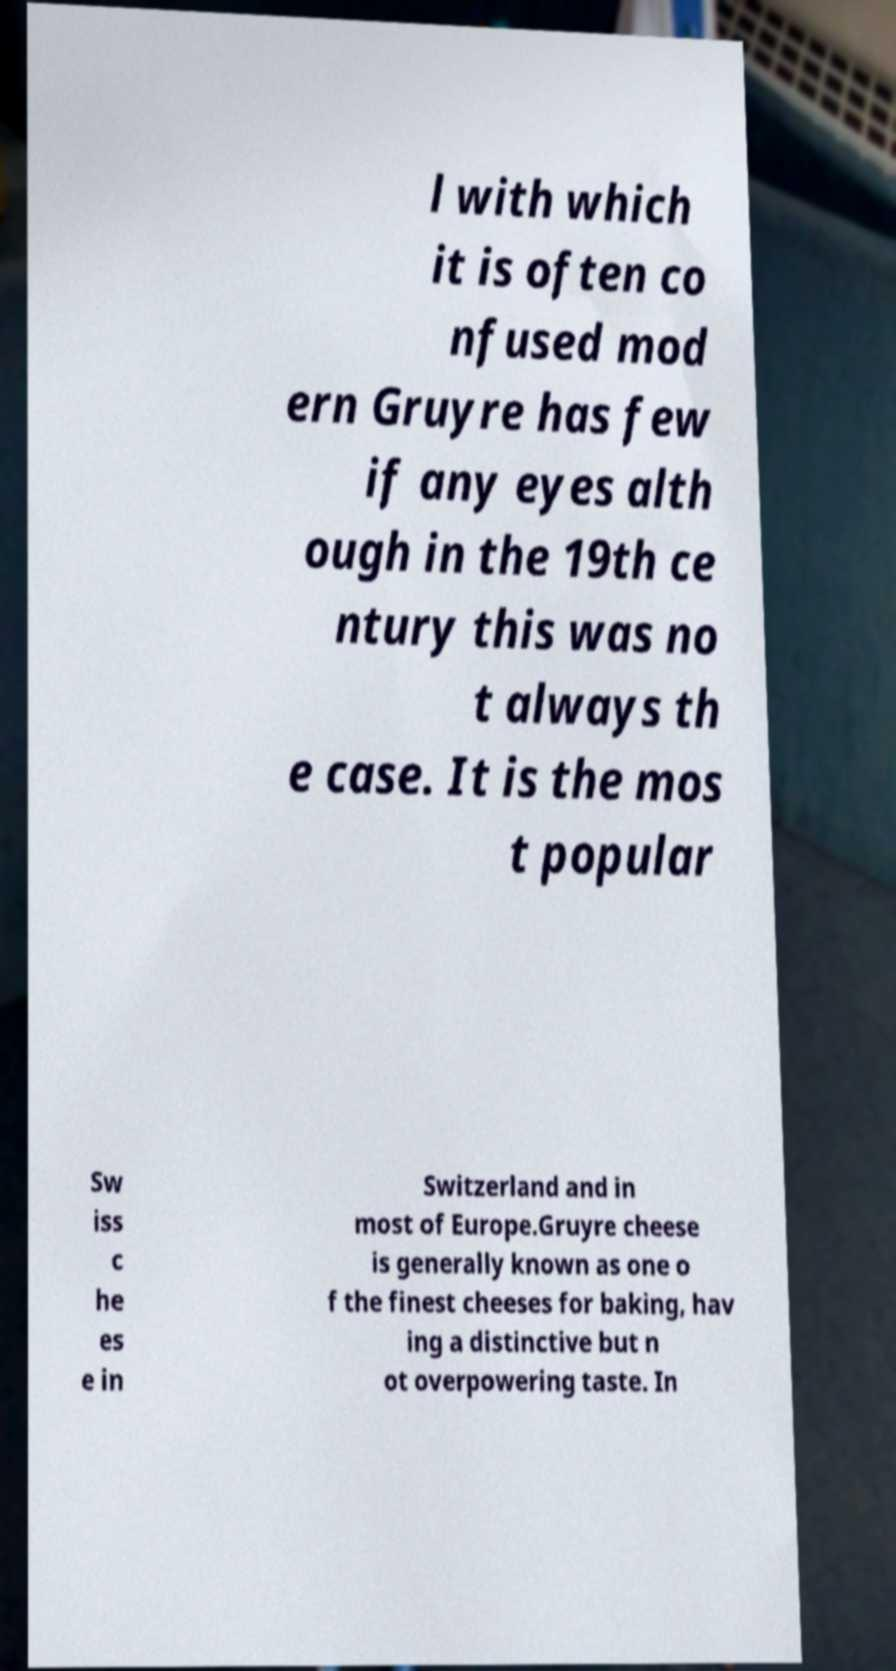Could you assist in decoding the text presented in this image and type it out clearly? l with which it is often co nfused mod ern Gruyre has few if any eyes alth ough in the 19th ce ntury this was no t always th e case. It is the mos t popular Sw iss c he es e in Switzerland and in most of Europe.Gruyre cheese is generally known as one o f the finest cheeses for baking, hav ing a distinctive but n ot overpowering taste. In 